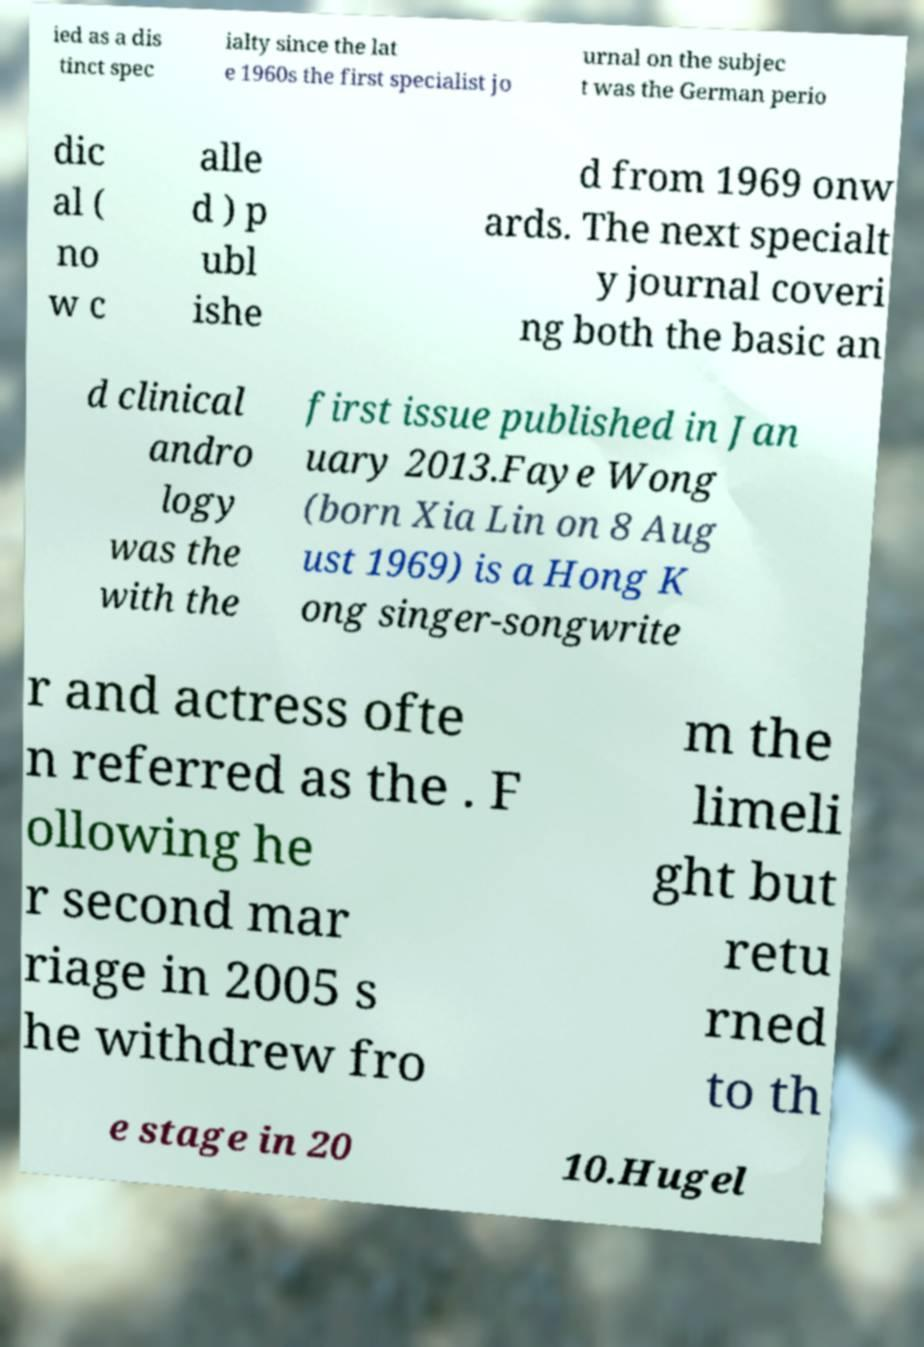I need the written content from this picture converted into text. Can you do that? ied as a dis tinct spec ialty since the lat e 1960s the first specialist jo urnal on the subjec t was the German perio dic al ( no w c alle d ) p ubl ishe d from 1969 onw ards. The next specialt y journal coveri ng both the basic an d clinical andro logy was the with the first issue published in Jan uary 2013.Faye Wong (born Xia Lin on 8 Aug ust 1969) is a Hong K ong singer-songwrite r and actress ofte n referred as the . F ollowing he r second mar riage in 2005 s he withdrew fro m the limeli ght but retu rned to th e stage in 20 10.Hugel 